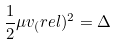<formula> <loc_0><loc_0><loc_500><loc_500>\frac { 1 } { 2 } \mu v _ { ( } r e l ) ^ { 2 } = \Delta</formula> 